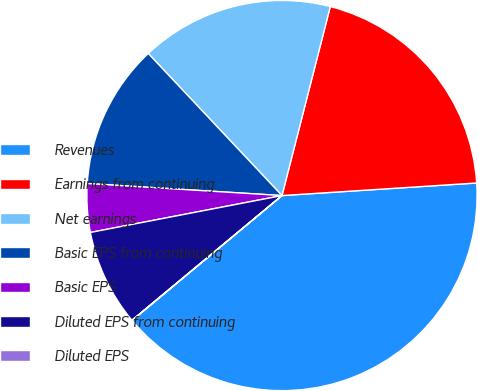Convert chart to OTSL. <chart><loc_0><loc_0><loc_500><loc_500><pie_chart><fcel>Revenues<fcel>Earnings from continuing<fcel>Net earnings<fcel>Basic EPS from continuing<fcel>Basic EPS<fcel>Diluted EPS from continuing<fcel>Diluted EPS<nl><fcel>39.97%<fcel>19.99%<fcel>16.0%<fcel>12.0%<fcel>4.01%<fcel>8.01%<fcel>0.02%<nl></chart> 